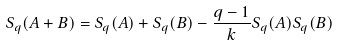Convert formula to latex. <formula><loc_0><loc_0><loc_500><loc_500>S _ { q } ( A + B ) = S _ { q } ( A ) + S _ { q } ( B ) - \frac { q - 1 } { k } S _ { q } ( A ) S _ { q } ( B )</formula> 